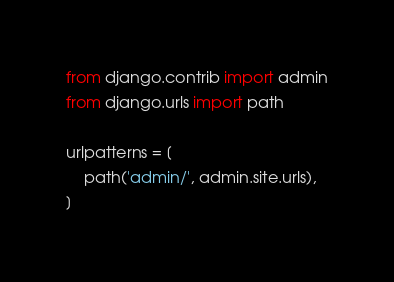Convert code to text. <code><loc_0><loc_0><loc_500><loc_500><_Python_>from django.contrib import admin
from django.urls import path

urlpatterns = [
    path('admin/', admin.site.urls),
]
</code> 